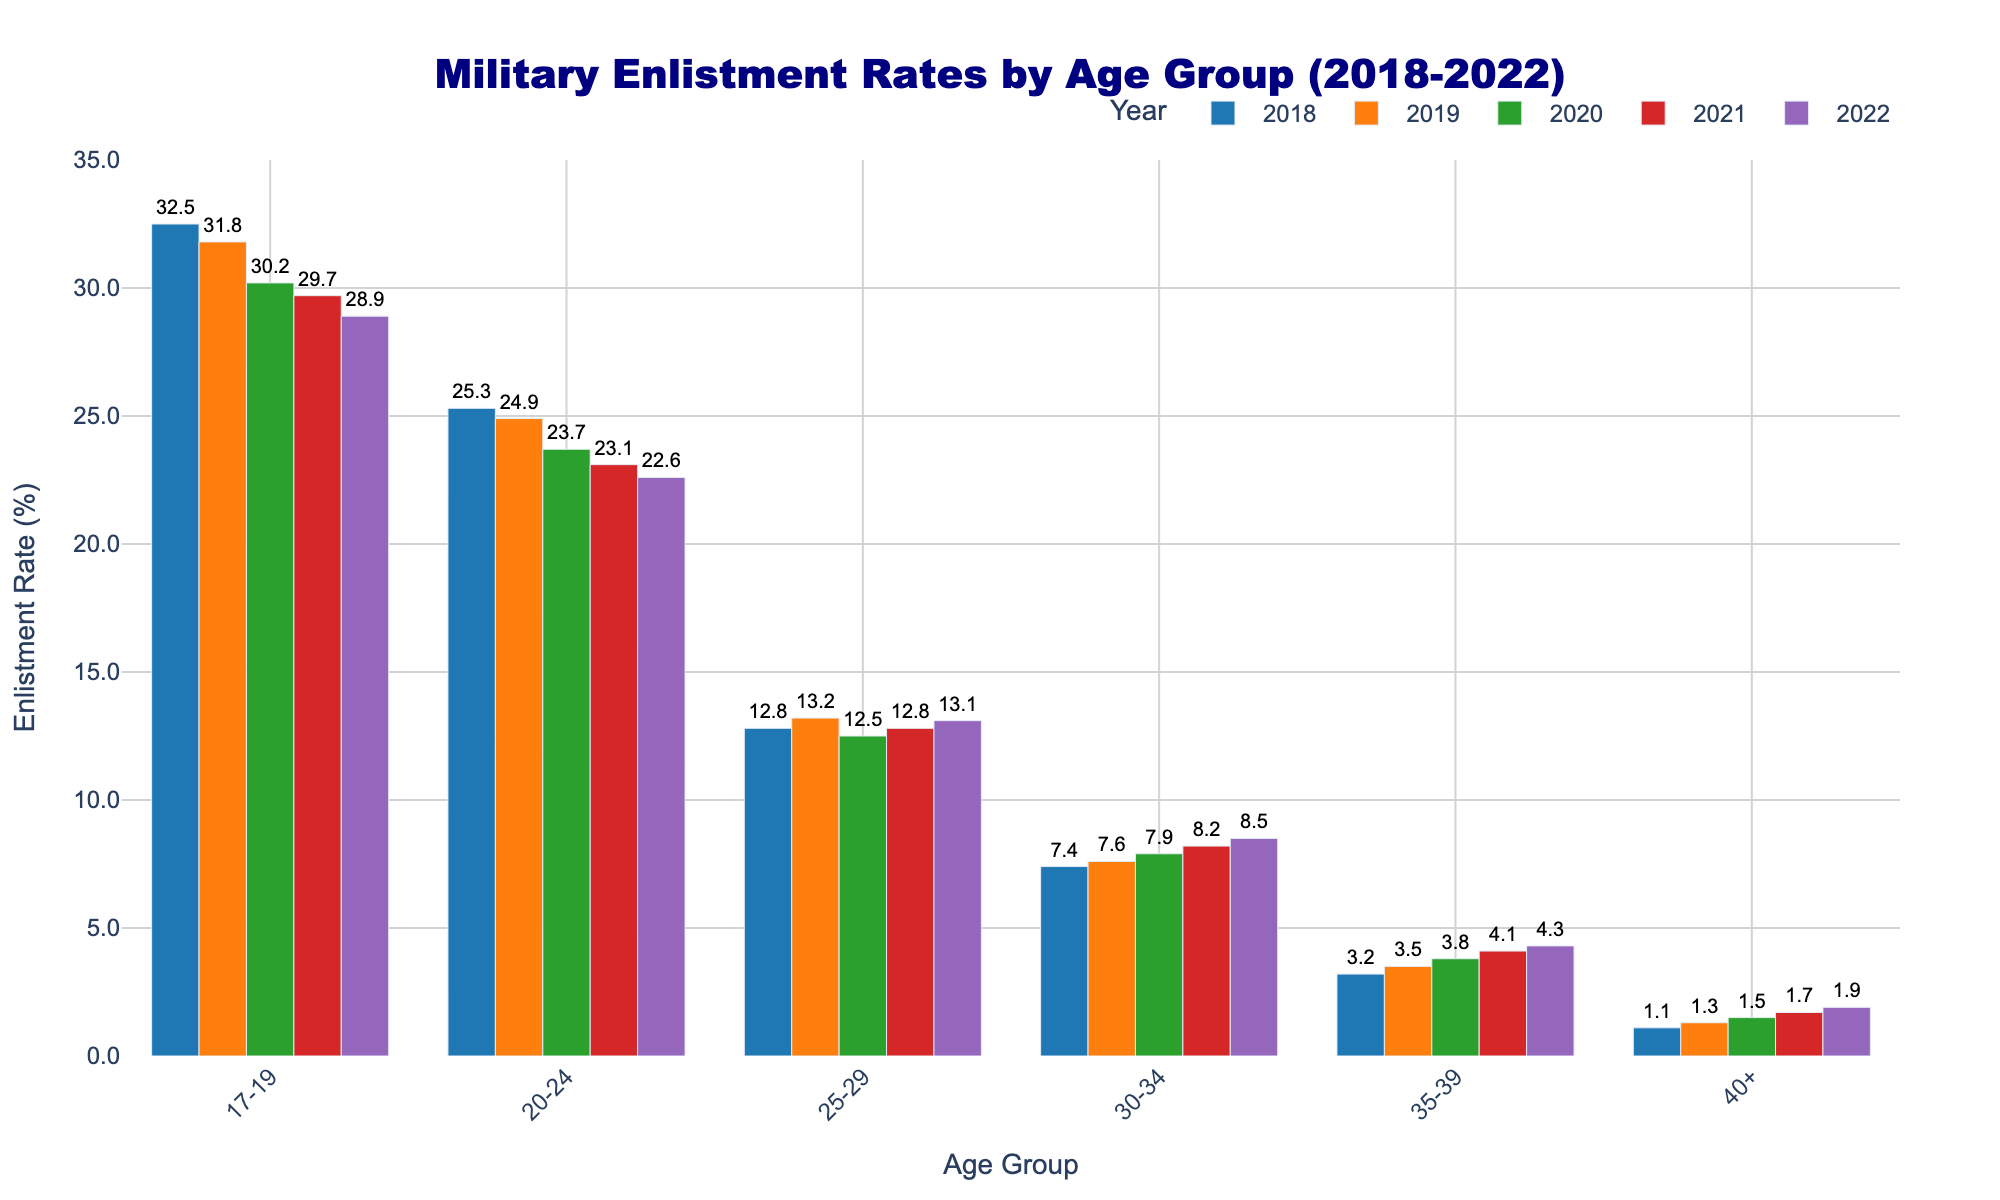What is the enlistment rate for the age group 17-19 in the year 2022? Find the bar associated with the age group 17-19 for the year 2022 and observe its height. The text label on top provides the exact value.
Answer: 28.9% Which age group saw the largest increase in enlistment rate from 2018 to 2022? Observe the enlistment rates for each age group in 2018 and 2022. Calculate the difference for each age group and identify the largest positive change.
Answer: 40+ How do the enlistment rates for the age group 30-34 compare between 2018 and 2022? Look at the height of the bars for the age group 30-34 in both 2018 and 2022. Compare their values to see the difference.
Answer: 8.5% in 2022, 7.4% in 2018 (increase) What is the trend in enlistment rates for the age group 25-29 from 2018 to 2022? Follow the bars for the age group 25-29 from left to right (2018 to 2022) and observe if the values increase, decrease, or remain stable over the years.
Answer: Slightly increasing Which age group had the lowest enlistment rate in 2021? Identify the smallest bar in the year 2021 across all age groups.
Answer: 40+ Combining the enlistment rates of 30-34 and 35-39 age groups in 2022, what is the total rate? Add the enlistment rates for the age groups 30-34 and 35-39 from the year 2022.
Answer: 12.8% Which year saw the highest enlistment rate for the 20-24 age group and what was it? Look at the bars for the age group 20-24 across all years and identify the year with the highest bar and its corresponding value.
Answer: 2018, 25.3% Has the enlistment rate for the 40+ age group consistently increased every year from 2018 to 2022? Check the bars for the 40+ age group from 2018 to 2022 and observe if the enlistment rate increases each year without any dip.
Answer: Yes In 2019, which age group had a higher enlistment rate: 17-19 or 25-29? Compare the bars for the age groups 17-19 and 25-29 in the year 2019.
Answer: 17-19 If you average the enlistment rates for age groups 20-24 and 25-29 in 2021, what is the result? Add the enlistment rates for the age groups 20-24 and 25-29 in 2021, then divide by 2.
Answer: 18.0% 